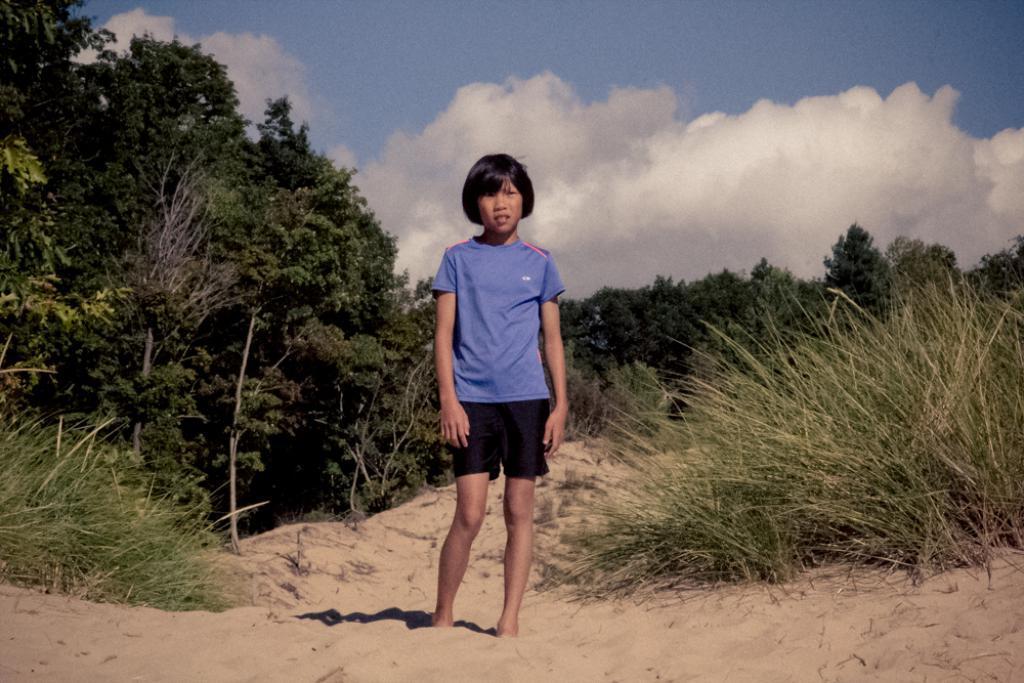Can you describe this image briefly? In this picture there is a girl who is wearing t-shirt and short. She is standing on the sand. Besides her I can see the plants. In the background I can see many trees. At the top I can see the sky and clouds. 